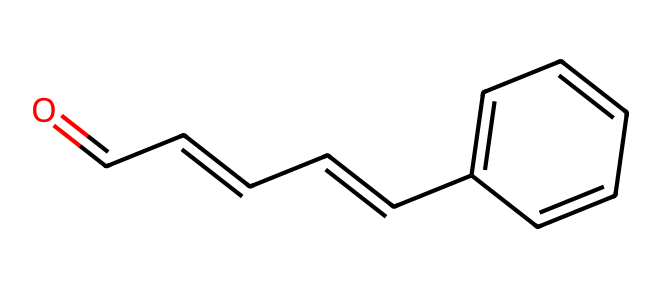What is the two-letter functional group in this molecule? The functional group is represented by the carbonyl group (C=O) attached to a carbon atom; this indicates the presence of an aldehyde.
Answer: aldehyde How many carbon atoms are in cinnamaldehyde? By analyzing the SMILES structure, there are a total of 9 carbon atoms linked in the chain and rings.
Answer: 9 What type of bond is found between the carbon and oxygen in the carbonyl group? The bond between the carbon and oxygen in the carbonyl group is a double bond, represented by the "=" sign in the SMILES string.
Answer: double bond What is the simplest aldehyde structure represented here? The aldehyde is defined by its functional carbonyl group bonded to a terminal carbon, and the simplest version can be seen with this structure as the aromatic ring is a complex variation.
Answer: formaldehyde How many rings are in the molecular structure of cinnamaldehyde? The structure contains one aromatic ring, indicated by the cyclic arrangement of carbon atoms and double bonds in the structure.
Answer: 1 What characteristic feature identifies this compound as part of the aromatic class? The presence of alternating double bonds and a closed ring structure denotes it as an aromatic compound, specifically the benzene-like portion of the molecule.
Answer: aromatic Which part of the molecule contributes to its distinct cinnamon aroma? The aldehyde functional group, particularly with its longer carbon chain attached to an aromatic ring, contributes significantly to the characteristic cinnamon fragrance.
Answer: aromatic chain 